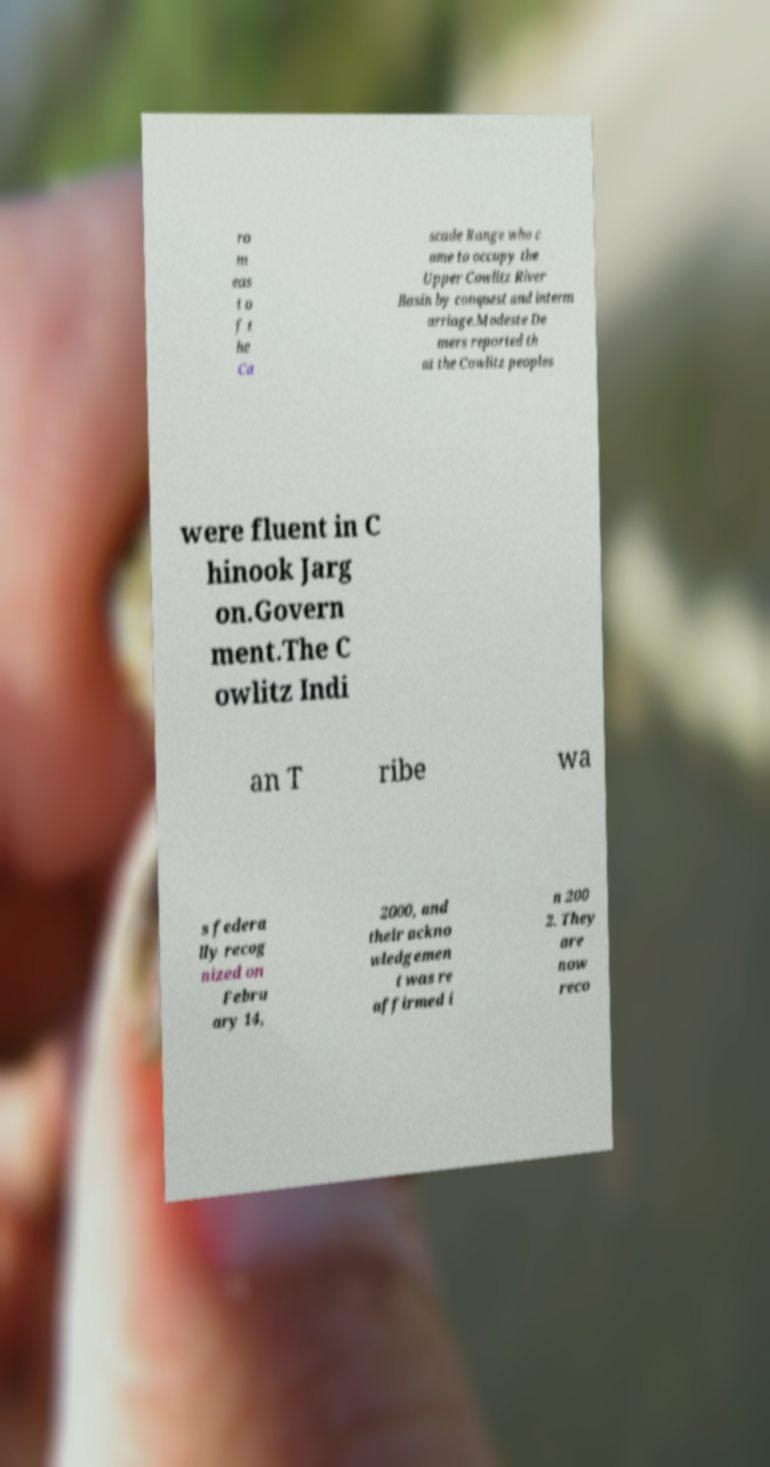Please read and relay the text visible in this image. What does it say? ro m eas t o f t he Ca scade Range who c ame to occupy the Upper Cowlitz River Basin by conquest and interm arriage.Modeste De mers reported th at the Cowlitz peoples were fluent in C hinook Jarg on.Govern ment.The C owlitz Indi an T ribe wa s federa lly recog nized on Febru ary 14, 2000, and their ackno wledgemen t was re affirmed i n 200 2. They are now reco 